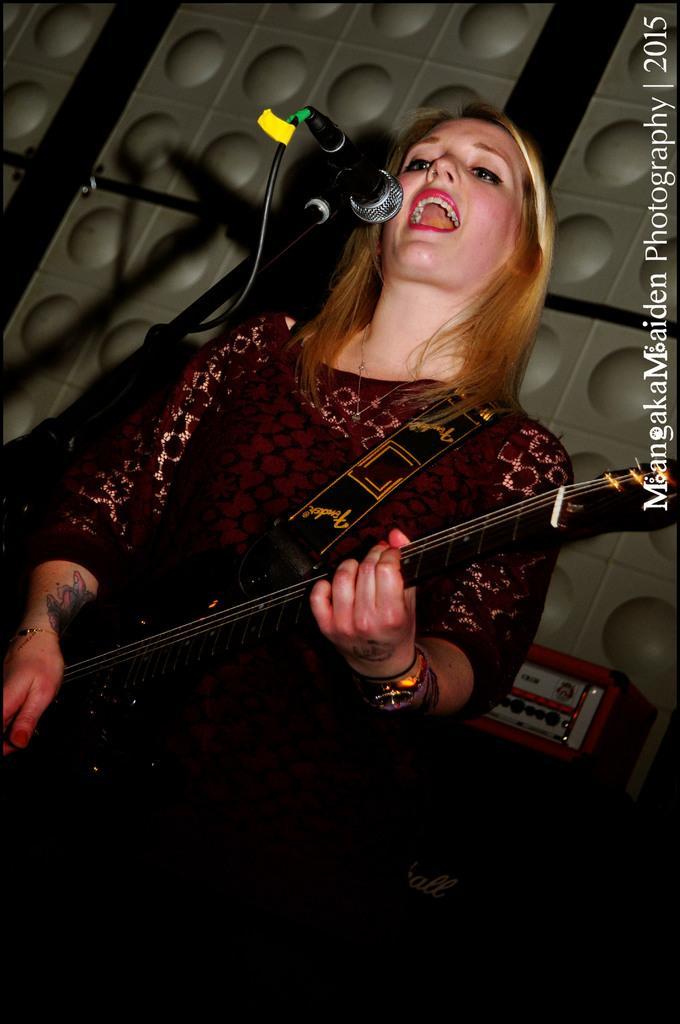Describe this image in one or two sentences. Woman playing guitar,this is microphone. 